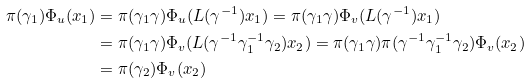<formula> <loc_0><loc_0><loc_500><loc_500>\pi ( \gamma _ { 1 } ) \Phi _ { u } ( x _ { 1 } ) & = \pi ( \gamma _ { 1 } \gamma ) \Phi _ { u } ( L ( \gamma ^ { - 1 } ) x _ { 1 } ) = \pi ( \gamma _ { 1 } \gamma ) \Phi _ { v } ( L ( \gamma ^ { - 1 } ) x _ { 1 } ) \\ & = \pi ( \gamma _ { 1 } \gamma ) \Phi _ { v } ( L ( \gamma ^ { - 1 } \gamma _ { 1 } ^ { - 1 } \gamma _ { 2 } ) x _ { 2 } ) = \pi ( \gamma _ { 1 } \gamma ) \pi ( \gamma ^ { - 1 } \gamma _ { 1 } ^ { - 1 } \gamma _ { 2 } ) \Phi _ { v } ( x _ { 2 } ) \\ & = \pi ( \gamma _ { 2 } ) \Phi _ { v } ( x _ { 2 } )</formula> 